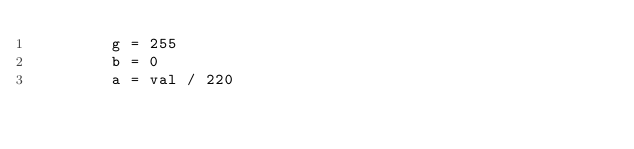<code> <loc_0><loc_0><loc_500><loc_500><_Python_>        g = 255
        b = 0
        a = val / 220</code> 